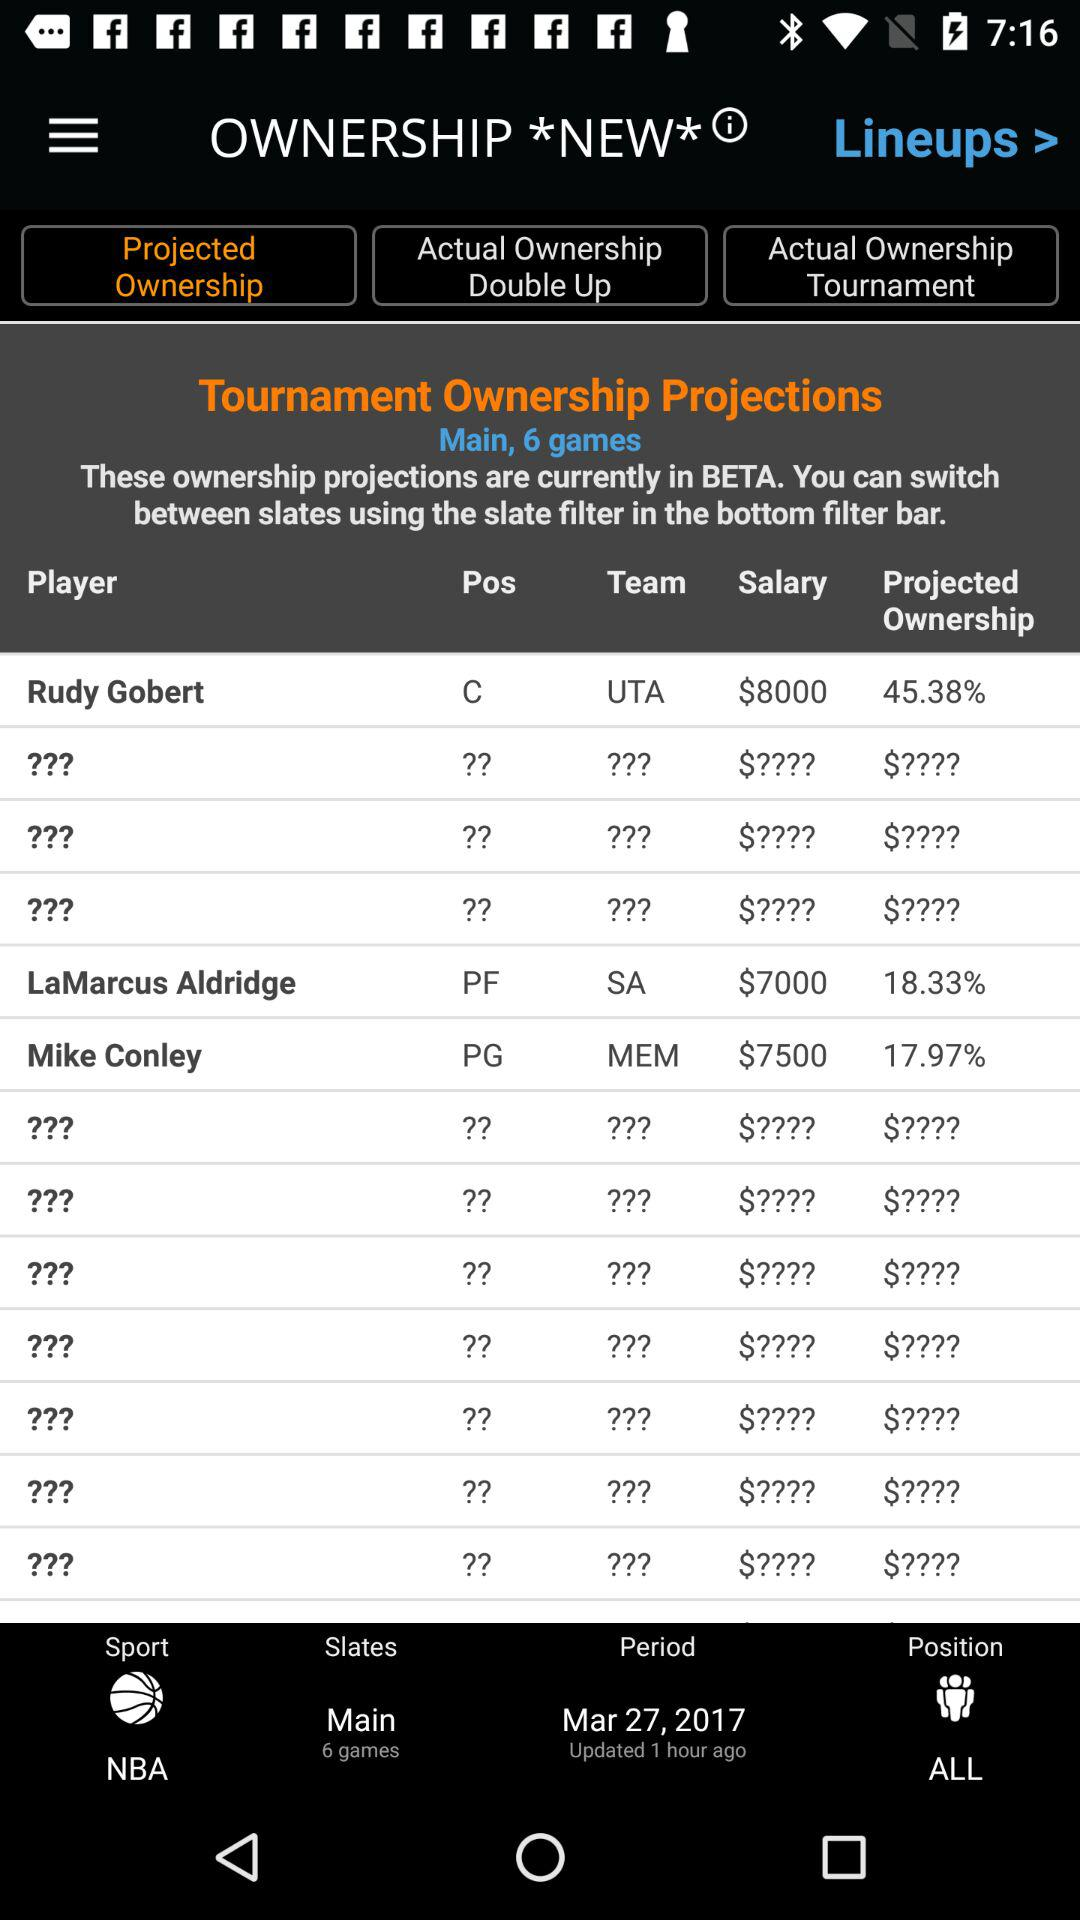What is the salary of Mike Conley? Mike Conley's salary is $7500. 